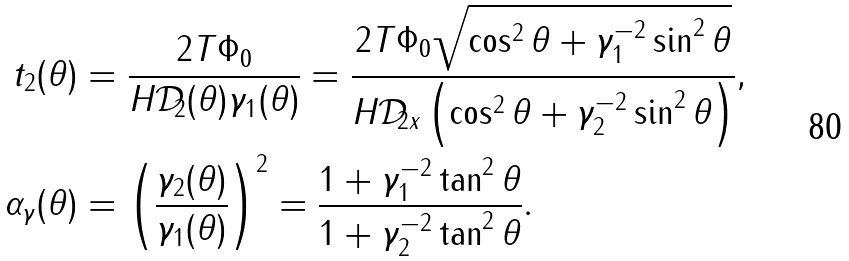Convert formula to latex. <formula><loc_0><loc_0><loc_500><loc_500>t _ { 2 } ( \theta ) & = \frac { 2 T \Phi _ { 0 } } { H \mathcal { D } _ { 2 } ( \theta ) \gamma _ { 1 } ( \theta ) } = \frac { 2 T \Phi _ { 0 } \sqrt { \cos ^ { 2 } \theta + \gamma _ { 1 } ^ { - 2 } \sin ^ { 2 } \theta } } { H \mathcal { D } _ { 2 x } \left ( \cos ^ { 2 } \theta + \gamma _ { 2 } ^ { - 2 } \sin ^ { 2 } \theta \right ) } , \\ \alpha _ { \gamma } ( \theta ) & = \left ( \frac { \gamma _ { 2 } ( \theta ) } { \gamma _ { 1 } ( \theta ) } \right ) ^ { 2 } = \frac { 1 + \gamma _ { 1 } ^ { - 2 } \tan ^ { 2 } \theta } { 1 + \gamma _ { 2 } ^ { - 2 } \tan ^ { 2 } \theta } .</formula> 